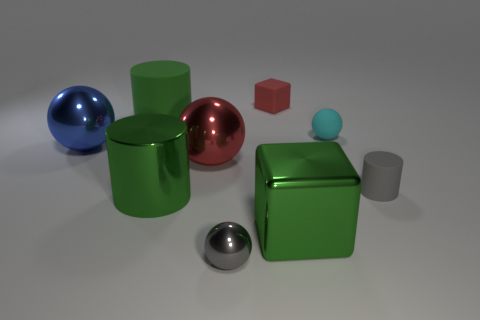What can the objects' reflections tell us about their surfaces? The reflections on the objects indicate that their surfaces vary in material properties. The blue and silver metallic spheres, as well as the green cylindrical can, exhibit clear, sharp reflections, suggesting smooth and possibly metal-like surfaces. The red cube has a less pronounced reflection, which could imply a slightly rougher texture. In contrast, the small gray cylinder and green cube appear matte, with no distinct reflections, indicating non-reflective surfaces. 